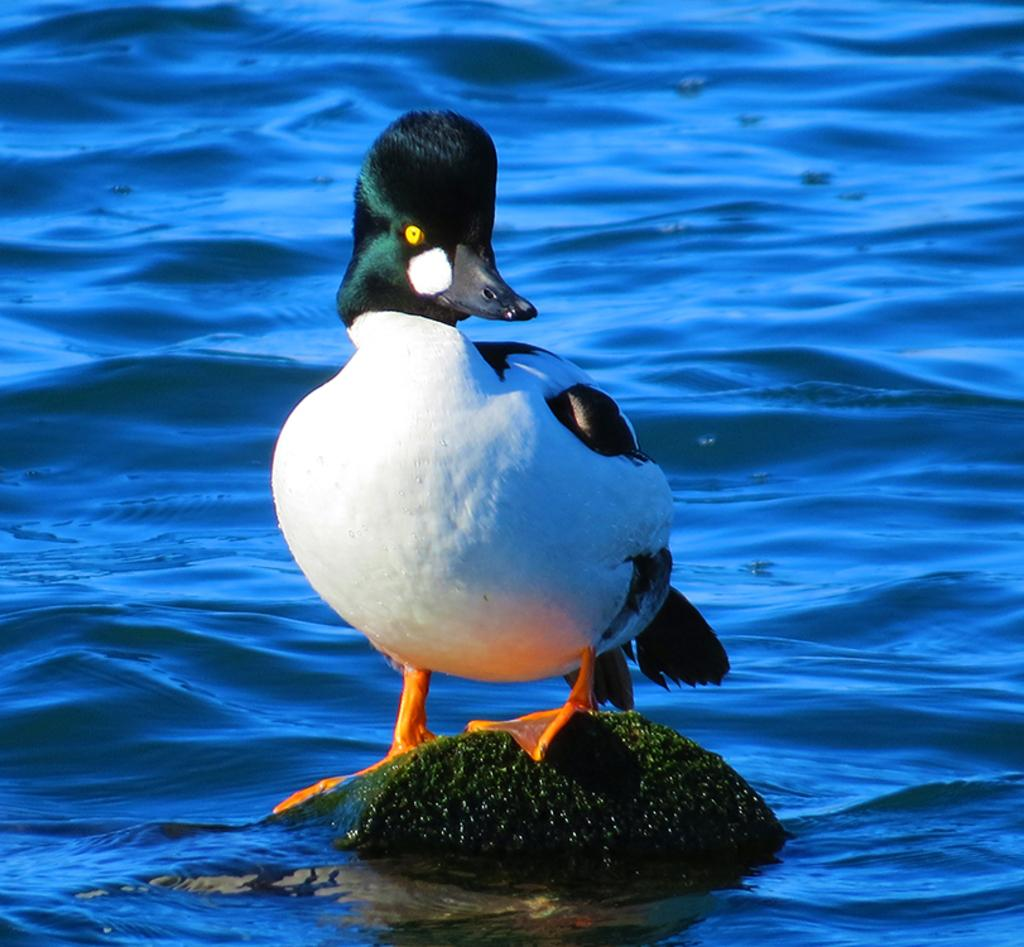What type of animal is in the image? There is a bird in the image. Can you identify the specific species of the bird? The bird is a common golden eye. What is the bird standing on in the image? The bird is standing on a rock. Where is the rock located in the image? The rock is in the water. What type of toys can be seen in the image? There are no toys present in the image; it features a bird standing on a rock in the water. 